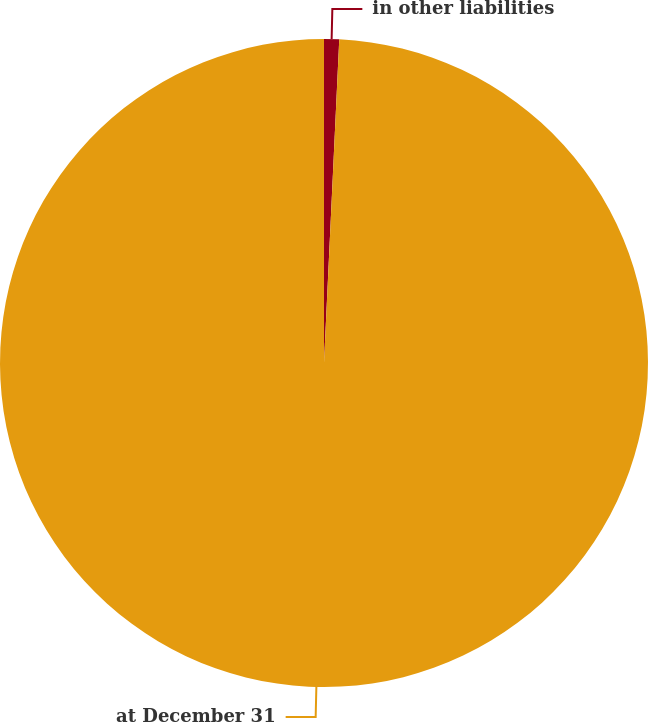Convert chart to OTSL. <chart><loc_0><loc_0><loc_500><loc_500><pie_chart><fcel>in other liabilities<fcel>at December 31<nl><fcel>0.75%<fcel>99.25%<nl></chart> 